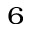Convert formula to latex. <formula><loc_0><loc_0><loc_500><loc_500>_ { 6 }</formula> 